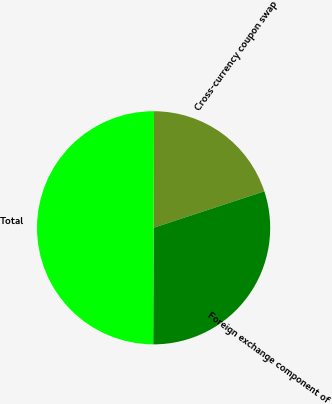<chart> <loc_0><loc_0><loc_500><loc_500><pie_chart><fcel>Cross-currency coupon swap<fcel>Foreign exchange component of<fcel>Total<nl><fcel>19.88%<fcel>30.12%<fcel>50.0%<nl></chart> 